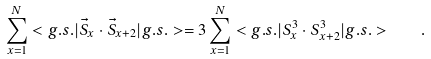Convert formula to latex. <formula><loc_0><loc_0><loc_500><loc_500>\sum _ { x = 1 } ^ { N } < g . s . | \vec { S } _ { x } \cdot \vec { S } _ { x + 2 } | g . s . > = 3 \sum _ { x = 1 } ^ { N } < g . s . | S ^ { 3 } _ { x } \cdot S ^ { 3 } _ { x + 2 } | g . s . > \quad .</formula> 